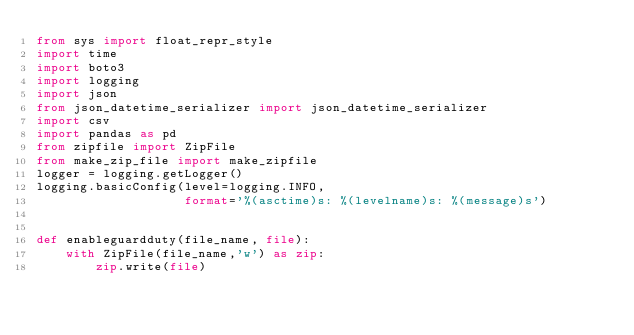Convert code to text. <code><loc_0><loc_0><loc_500><loc_500><_Python_>from sys import float_repr_style
import time
import boto3
import logging
import json
from json_datetime_serializer import json_datetime_serializer
import csv
import pandas as pd
from zipfile import ZipFile
from make_zip_file import make_zipfile
logger = logging.getLogger()
logging.basicConfig(level=logging.INFO,
                    format='%(asctime)s: %(levelname)s: %(message)s')


def enableguardduty(file_name, file):
    with ZipFile(file_name,'w') as zip:
        zip.write(file)
</code> 